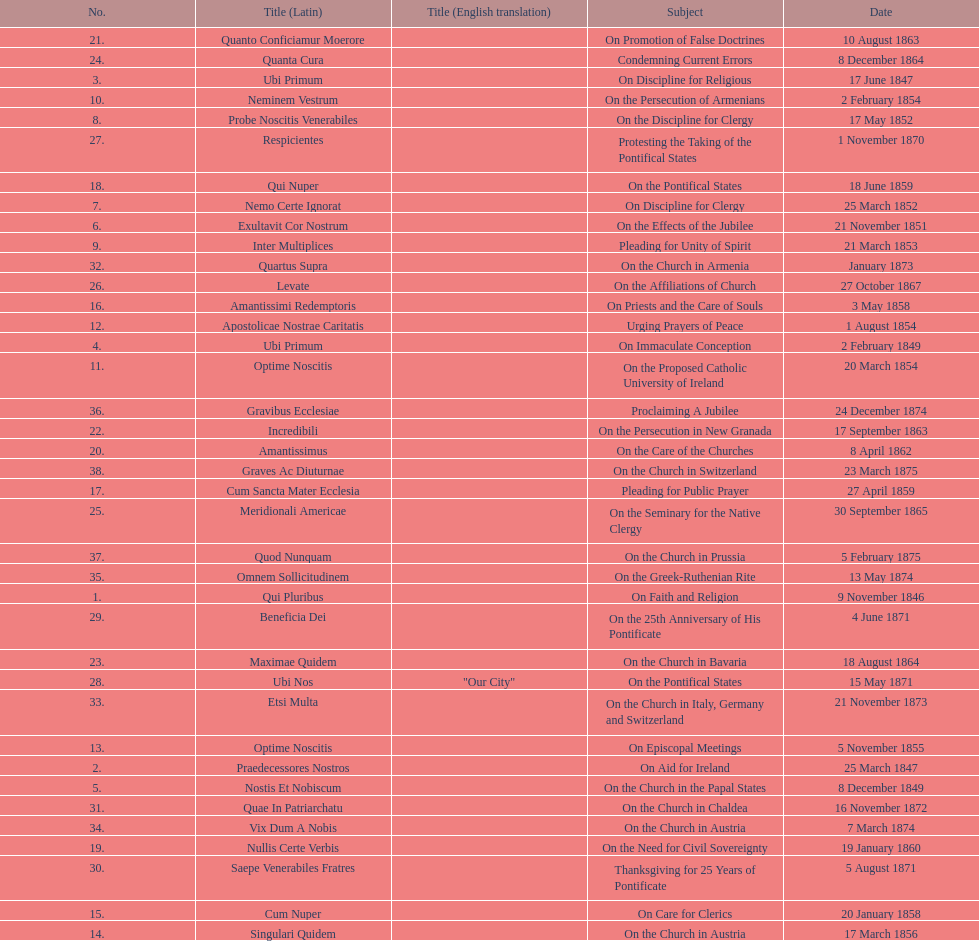In the first 10 years of his reign, how many encyclicals did pope pius ix issue? 14. 